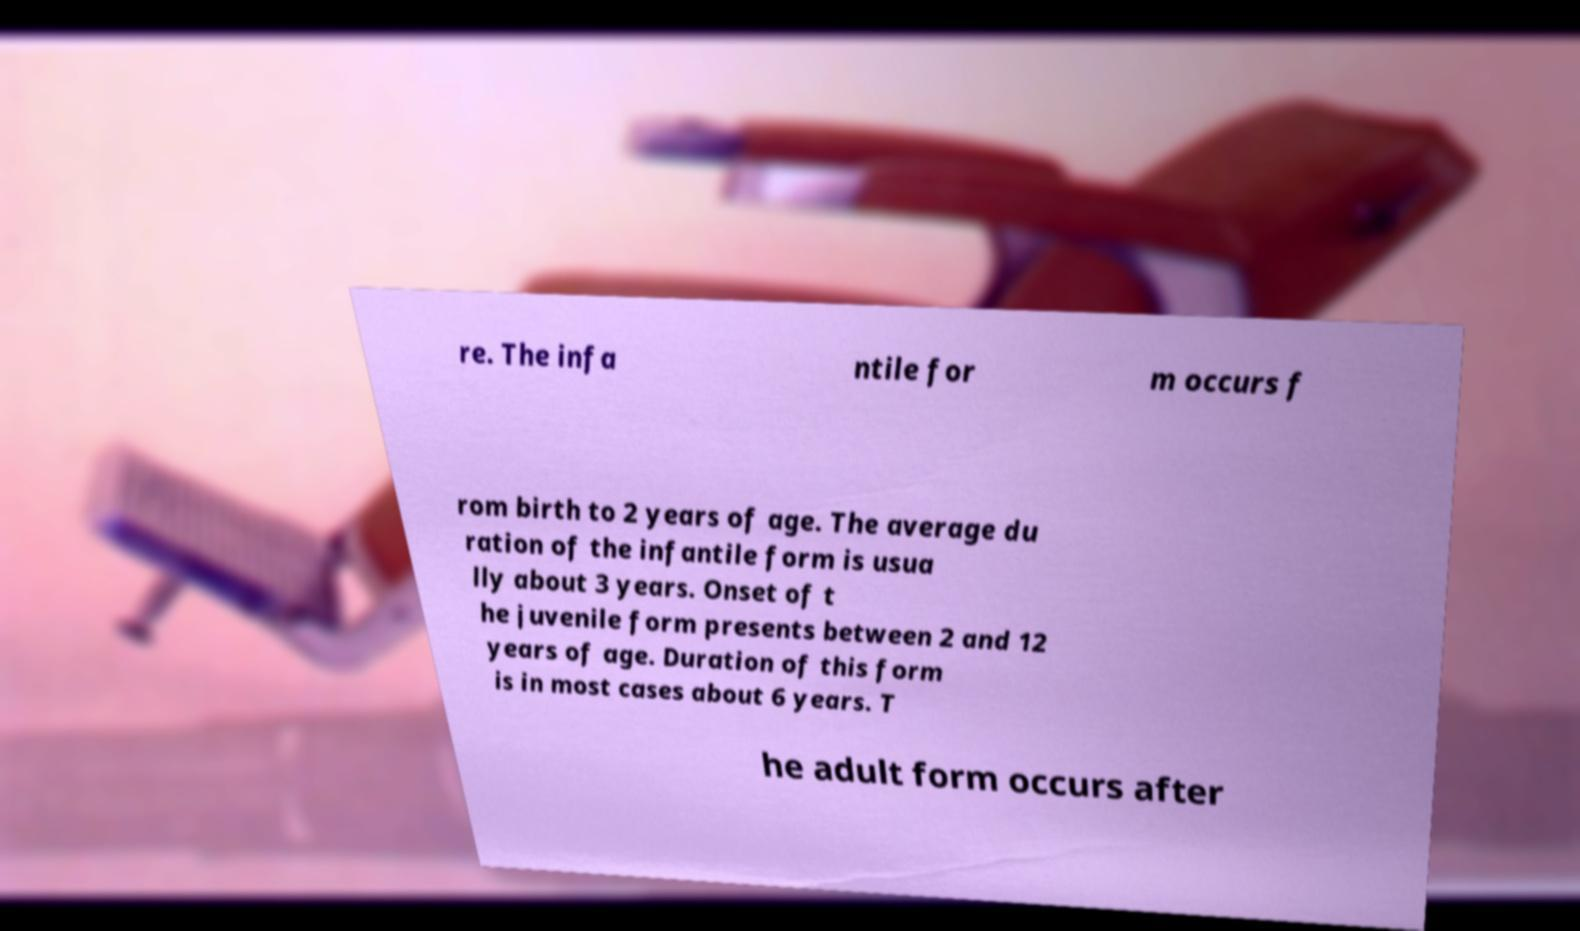Please identify and transcribe the text found in this image. re. The infa ntile for m occurs f rom birth to 2 years of age. The average du ration of the infantile form is usua lly about 3 years. Onset of t he juvenile form presents between 2 and 12 years of age. Duration of this form is in most cases about 6 years. T he adult form occurs after 